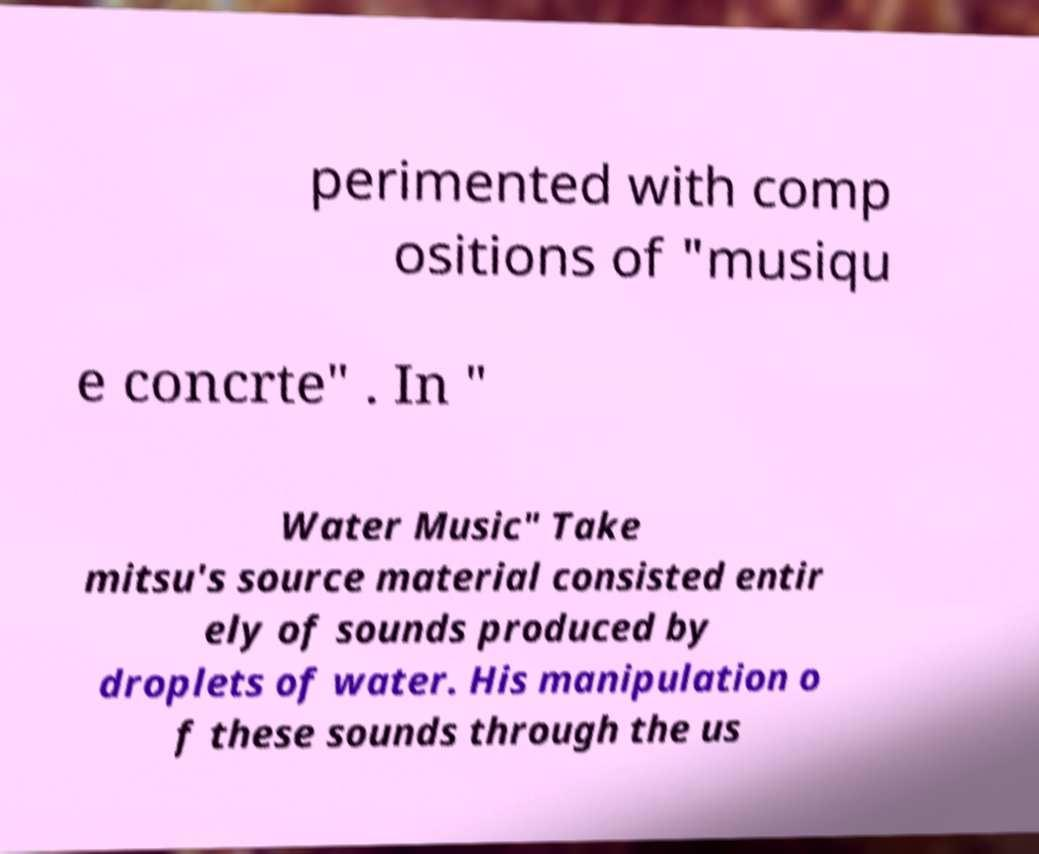For documentation purposes, I need the text within this image transcribed. Could you provide that? perimented with comp ositions of "musiqu e concrte" . In " Water Music" Take mitsu's source material consisted entir ely of sounds produced by droplets of water. His manipulation o f these sounds through the us 